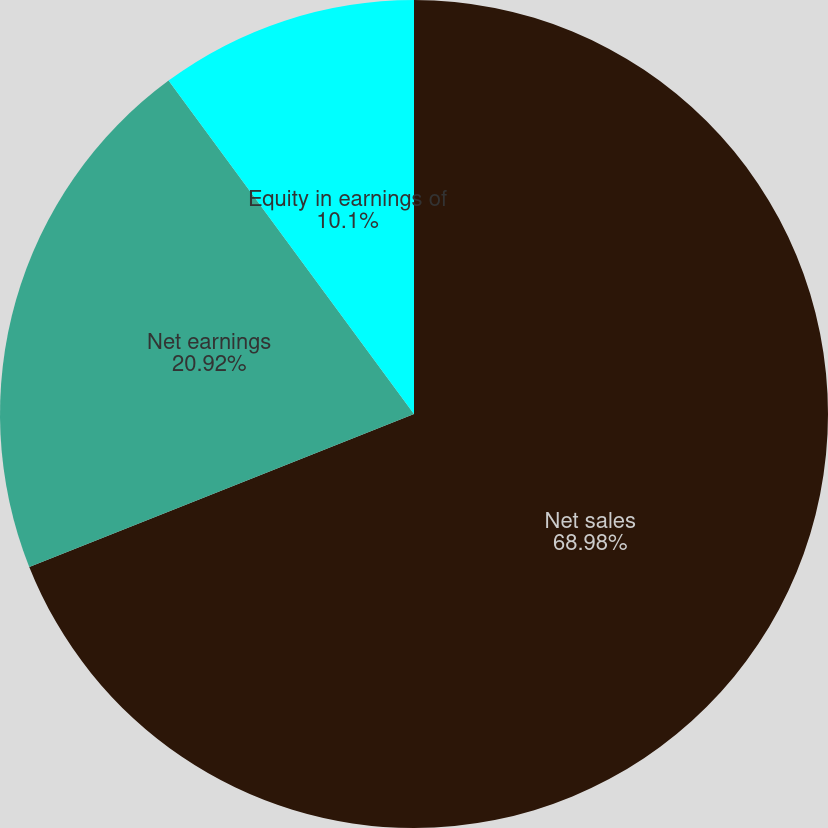<chart> <loc_0><loc_0><loc_500><loc_500><pie_chart><fcel>Net sales<fcel>Net earnings<fcel>Equity in earnings of<nl><fcel>68.98%<fcel>20.92%<fcel>10.1%<nl></chart> 